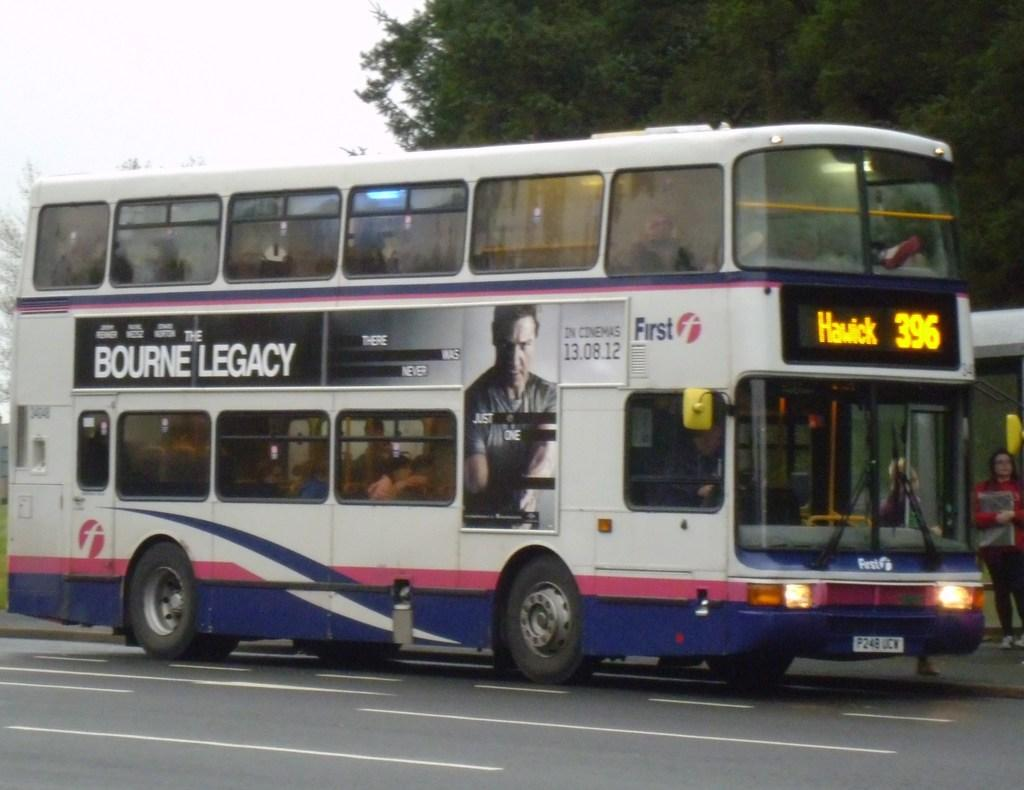<image>
Give a short and clear explanation of the subsequent image. Bus number 396 has an ad for The Bourne Legacy. 